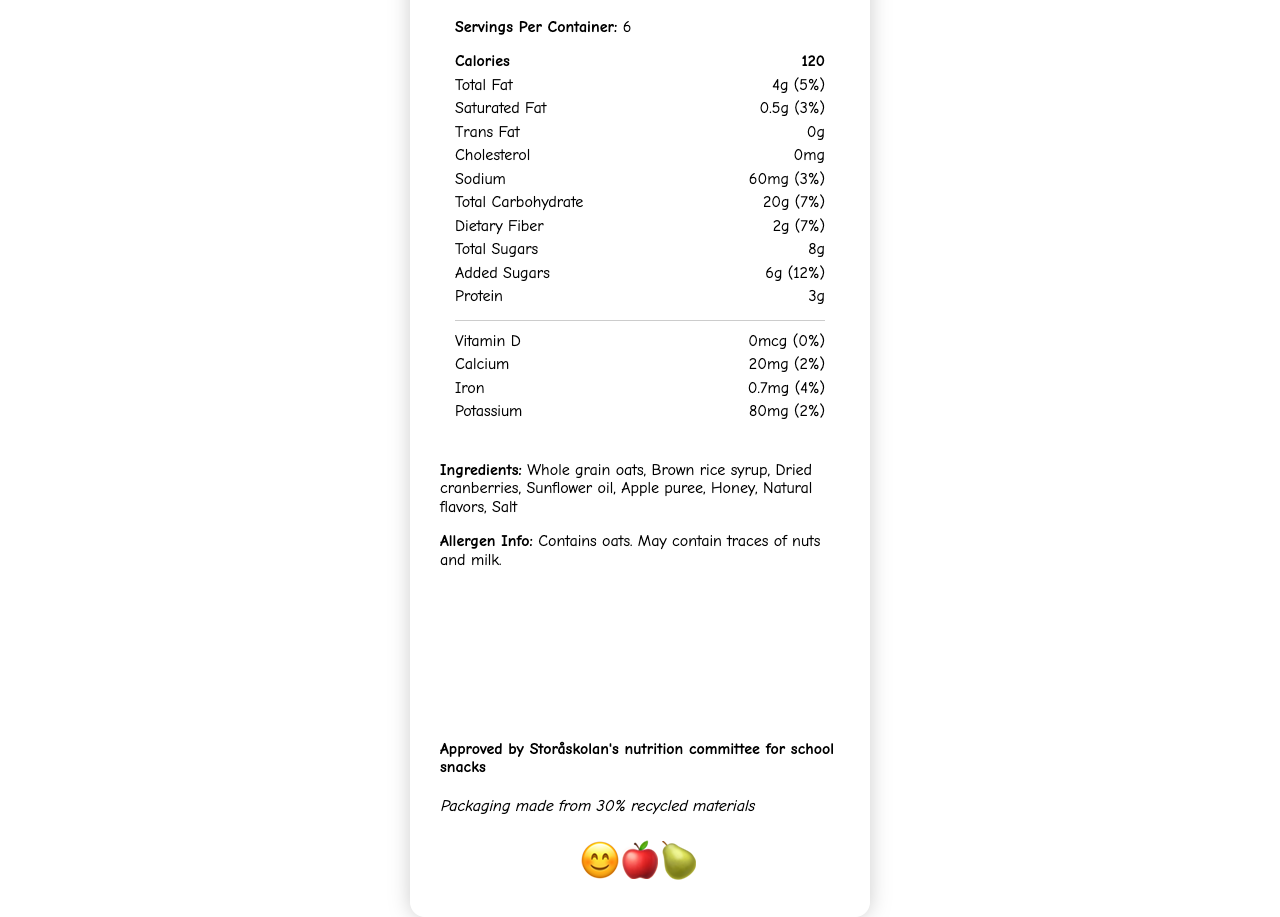How many servings are in one container of Fruity Oat Bars? According to the nutrition label, there are 6 servings per container.
Answer: 6 What is the serving size for Fruity Oat Bars? The document states that the serving size is 1 bar (30g).
Answer: 1 bar (30g) How many calories are in one serving of Fruity Oat Bars? The nutrition label lists the calorie content per serving as 120 calories.
Answer: 120 What percentage of the daily value for total fat does one serving have? The nutrition label specifies that one serving contains 4g of total fat, which is 5% of the daily value.
Answer: 5% How much protein is in one serving of Fruity Oat Bars? The document mentions that each serving contains 3g of protein.
Answer: 3g Which is NOT a health claim made on the Fruity Oat Bars label? A. Good source of fiber B. Contains no nuts C. Made with whole grains The label states "Good source of fiber" and "Made with whole grains," but does not make the claim "Contains no nuts."
Answer: B What is the percentage of daily value for added sugars in one serving? A. 6% B. 12% C. 18% D. None The document indicates that added sugars constitute 12% of the daily value per serving.
Answer: B Does the product contain any trans fat? According to the nutrition label, there is 0g of trans fat in one serving.
Answer: No Is the packaging eco-friendly? The document mentions that the packaging is made from 30% recycled materials.
Answer: Yes What are the allergens mentioned in the document? The allergen information specifies that the product contains oats and may contain traces of nuts and milk.
Answer: Oats; may contain traces of nuts and milk Summarize the main idea of the Fruity Oat Bars document. The document provides a comprehensive nutritional profile along with health claims and company manufacturing details, emphasizing its suitability for children and environmental friendliness.
Answer: Fruity Oat Bars are marketed as a wholesome, child-friendly snack, boasting a number of health benefits such as being a good source of fiber and made with whole grains. The label describes its nutritional content, includes potential allergens, and mentions the product's eco-friendly packaging and approval by Storåskolan's nutrition committee. What is the mascot for the Fruity Oat Bars product? The design elements section mentions the mascot as a smiley fruit character, reinforced by the emoji display of a smiling face with fruits.
Answer: Smiley fruit character What company manufactures Fruity Oat Bars? The manufacturer listed in the document is Healthy Kidz Snacks AB.
Answer: Healthy Kidz Snacks AB What is the amount of dietary fiber in one serving? The nutrition label states that one serving contains 2g of dietary fiber.
Answer: 2g How many milligrams of potassium are in one serving? The amount of potassium per serving is listed as 80mg in the nutrition label.
Answer: 80mg How much saturated fat is in one serving of Fruity Oat Bars? The document specifies that there is 0.5g of saturated fat per serving.
Answer: 0.5g Is the Fruity Oat Bars product approved by Storåskolan's nutrition committee? The document states that the product is approved by Storåskolan's nutrition committee for school snacks.
Answer: Yes Can you determine the exact price of a box of Fruity Oat Bars from the document? The document does not provide any pricing information.
Answer: Not enough information What are the primary visual colors used in the design of Fruity Oat Bars packaging? The primary color is listed as #FFA500 (orange), the secondary color as #32CD32 (green), and the accent color as #FF69B4 (pink).
Answer: Orange, green, and pink 